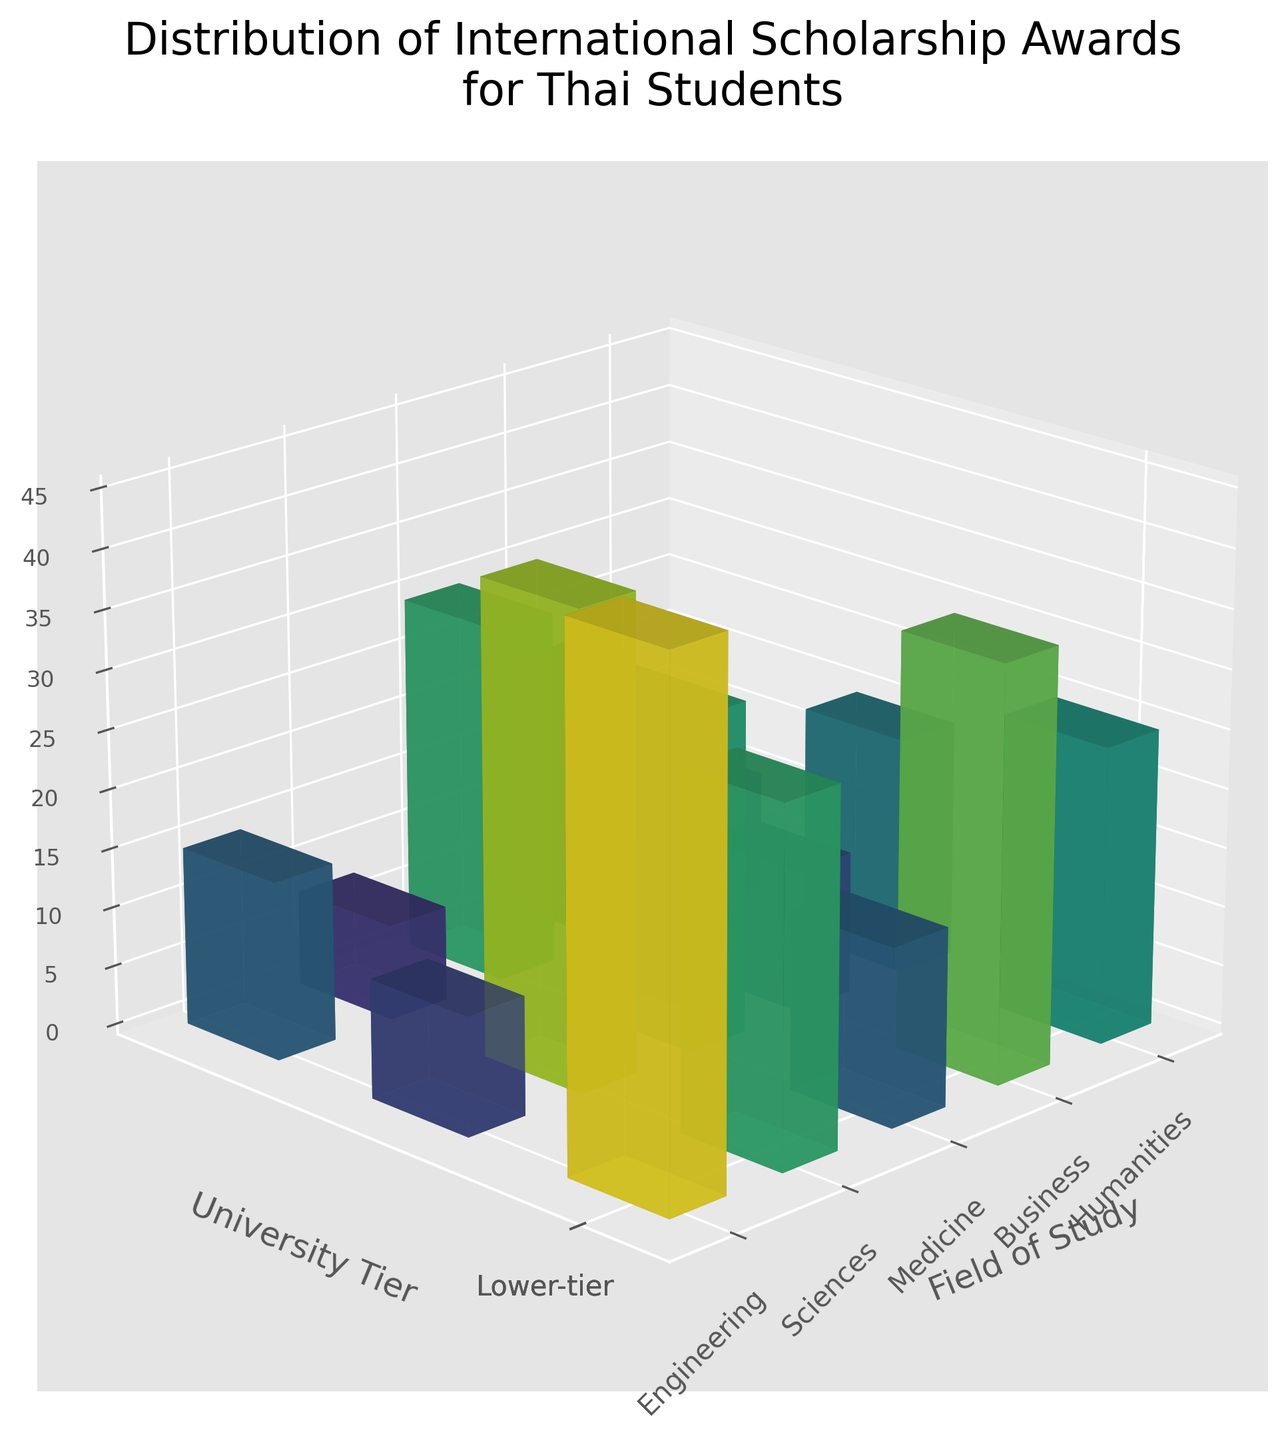Which field of study has the highest number of scholarship awards for top-tier universities? The figure shows the number of scholarship awards on the z-axis, categorized by field of study on the x-axis and university tier on the y-axis. For top-tier universities (front part of the y-axis), check the highest z-values among the fields of study.
Answer: Engineering What is the total number of scholarship awards for Humanities across all university tiers? Sum the scholarship awards of Humanities for each university tier: Top-tier (20), Mid-tier (15), and Lower-tier (8). Therefore, 20 + 15 + 8 = 43.
Answer: 43 Which university tier has the least number of scholarship awards for Medicine? Check the bar for Medicine on the x-axis and compare the heights of the bars for the three university tiers. The Lower-tier has the shortest bar for Medicine.
Answer: Lower-tier How many more scholarship awards does Sciences have at top-tier universities compared to mid-tier universities? Subtract the number of scholarship awards for mid-tier from those for top-tier in Sciences. For Sciences, Top-tier has 40 awards and Mid-tier has 28 awards. Therefore, 40 - 28 = 12.
Answer: 12 Which field of study has the lowest number of scholarship awards for Lower-tier universities? Look at the bars for the Lower-tier universities and find the field of study with the shortest bar. Humanities has the shortest bar with 8 awards.
Answer: Humanities What is the average number of scholarship awards for Business across the three university tiers? Sum the scholarship awards for Business across Top-tier (35), Mid-tier (25), and Lower-tier (10), then divide by 3. Therefore, (35 + 25 + 10) / 3 = 70 / 3 ≈ 23.33.
Answer: 23.33 Is the number of scholarship awards for Engineering in Mid-tier universities higher or lower than the number for Sciences in Lower-tier universities? Compare the bar height for Engineering in Mid-tier (30 awards) with the bar height for Sciences in Lower-tier (12 awards). Engineering in Mid-tier is higher.
Answer: Higher What is the difference in scholarship awards between the highest and lowest field of study for top-tier universities? Identify the highest number of awards (Engineering with 45) and the lowest number of awards (Humanities with 20) for top-tier universities. Difference = 45 - 20 = 25.
Answer: 25 